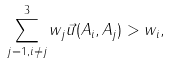Convert formula to latex. <formula><loc_0><loc_0><loc_500><loc_500>\| { \sum _ { j = 1 , i \ne j } ^ { 3 } w _ { j } \vec { u } ( A _ { i } , A _ { j } ) } \| > w _ { i } ,</formula> 